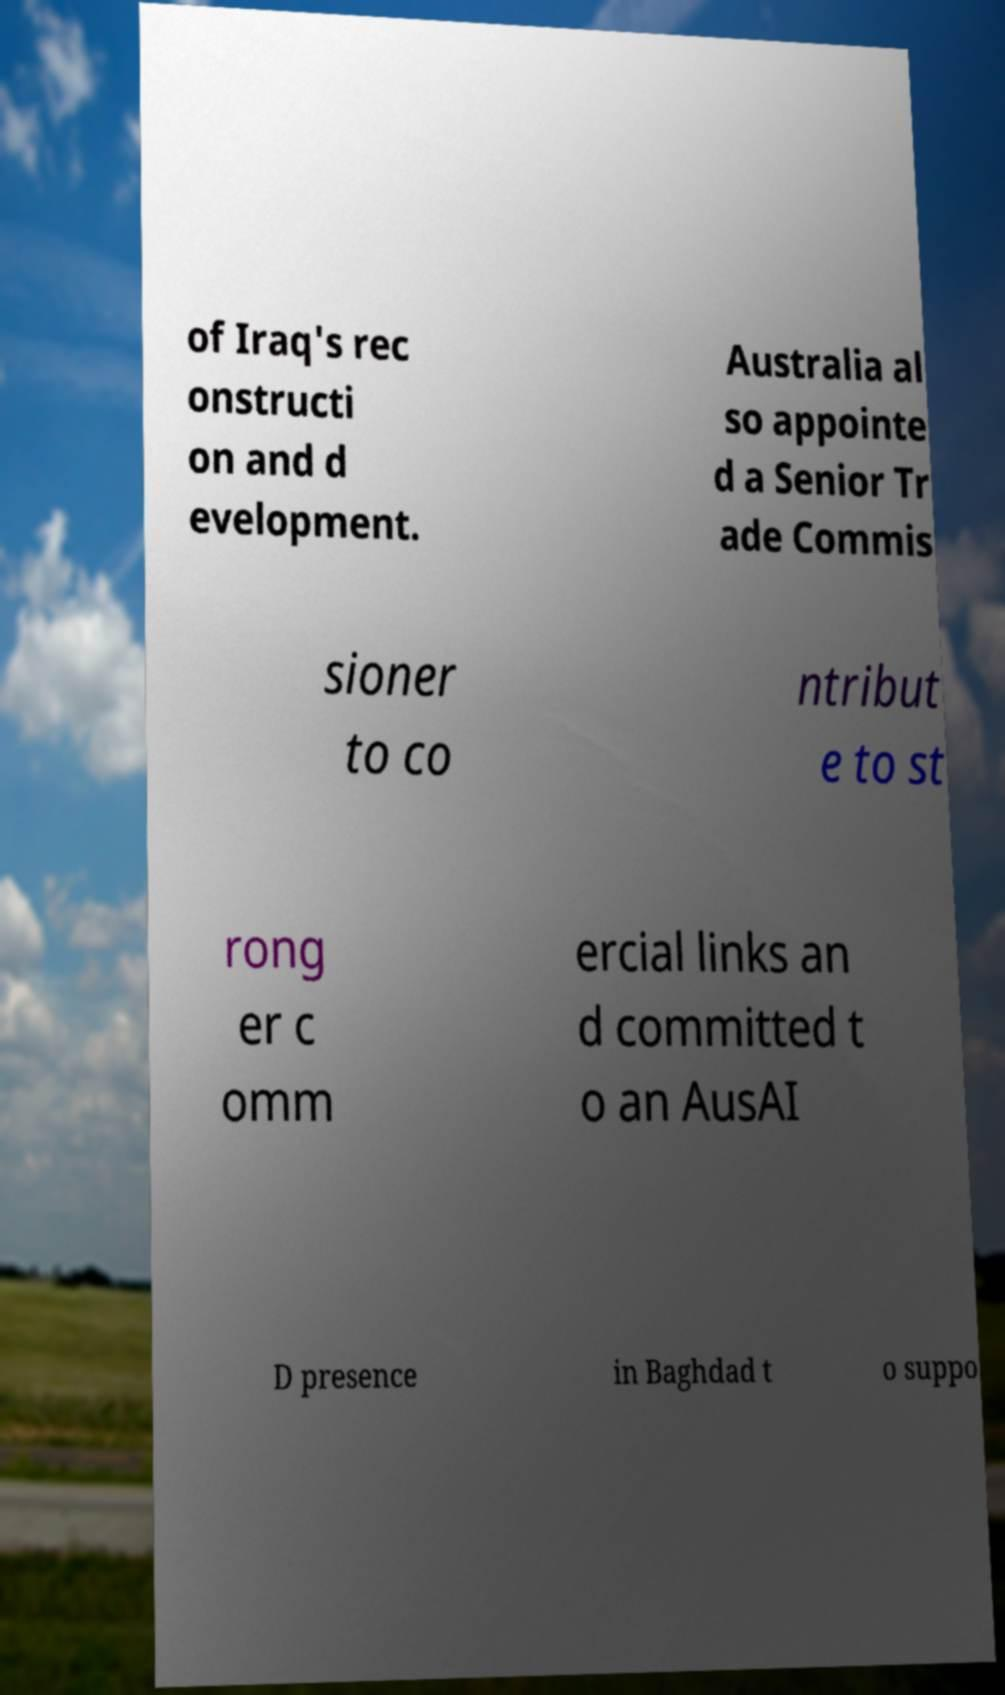There's text embedded in this image that I need extracted. Can you transcribe it verbatim? of Iraq's rec onstructi on and d evelopment. Australia al so appointe d a Senior Tr ade Commis sioner to co ntribut e to st rong er c omm ercial links an d committed t o an AusAI D presence in Baghdad t o suppo 